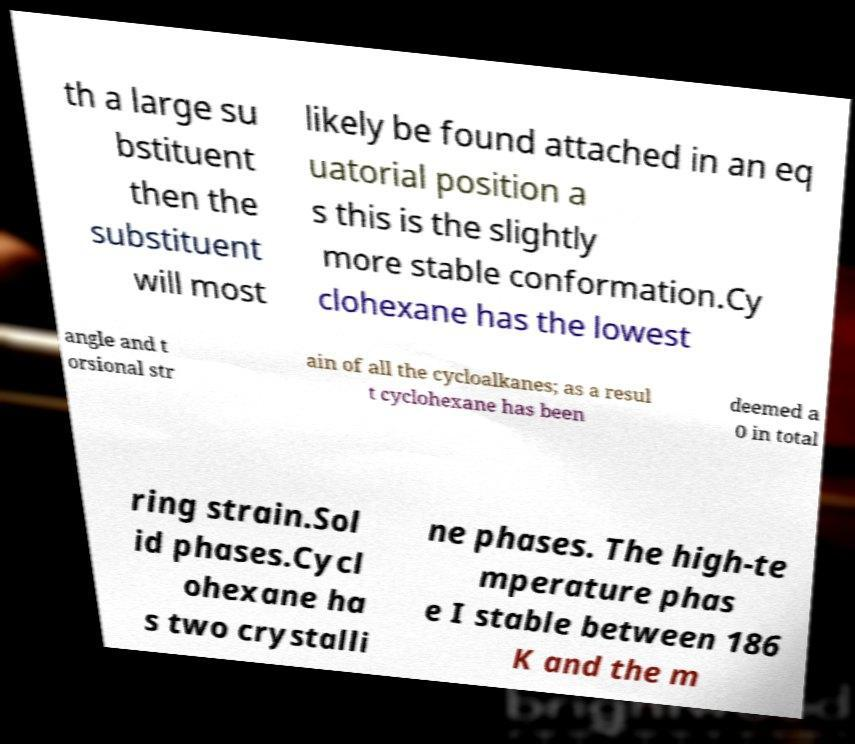Please identify and transcribe the text found in this image. th a large su bstituent then the substituent will most likely be found attached in an eq uatorial position a s this is the slightly more stable conformation.Cy clohexane has the lowest angle and t orsional str ain of all the cycloalkanes; as a resul t cyclohexane has been deemed a 0 in total ring strain.Sol id phases.Cycl ohexane ha s two crystalli ne phases. The high-te mperature phas e I stable between 186 K and the m 